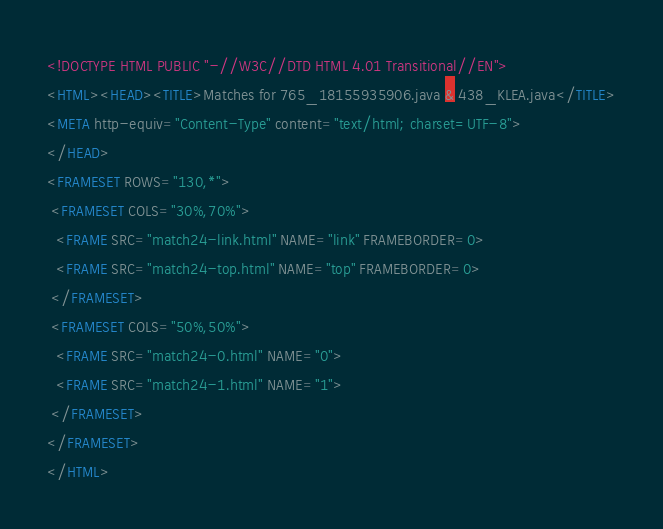Convert code to text. <code><loc_0><loc_0><loc_500><loc_500><_HTML_><!DOCTYPE HTML PUBLIC "-//W3C//DTD HTML 4.01 Transitional//EN">
<HTML><HEAD><TITLE>Matches for 765_18155935906.java & 438_KLEA.java</TITLE>
<META http-equiv="Content-Type" content="text/html; charset=UTF-8">
</HEAD>
<FRAMESET ROWS="130,*">
 <FRAMESET COLS="30%,70%">
  <FRAME SRC="match24-link.html" NAME="link" FRAMEBORDER=0>
  <FRAME SRC="match24-top.html" NAME="top" FRAMEBORDER=0>
 </FRAMESET>
 <FRAMESET COLS="50%,50%">
  <FRAME SRC="match24-0.html" NAME="0">
  <FRAME SRC="match24-1.html" NAME="1">
 </FRAMESET>
</FRAMESET>
</HTML>
</code> 